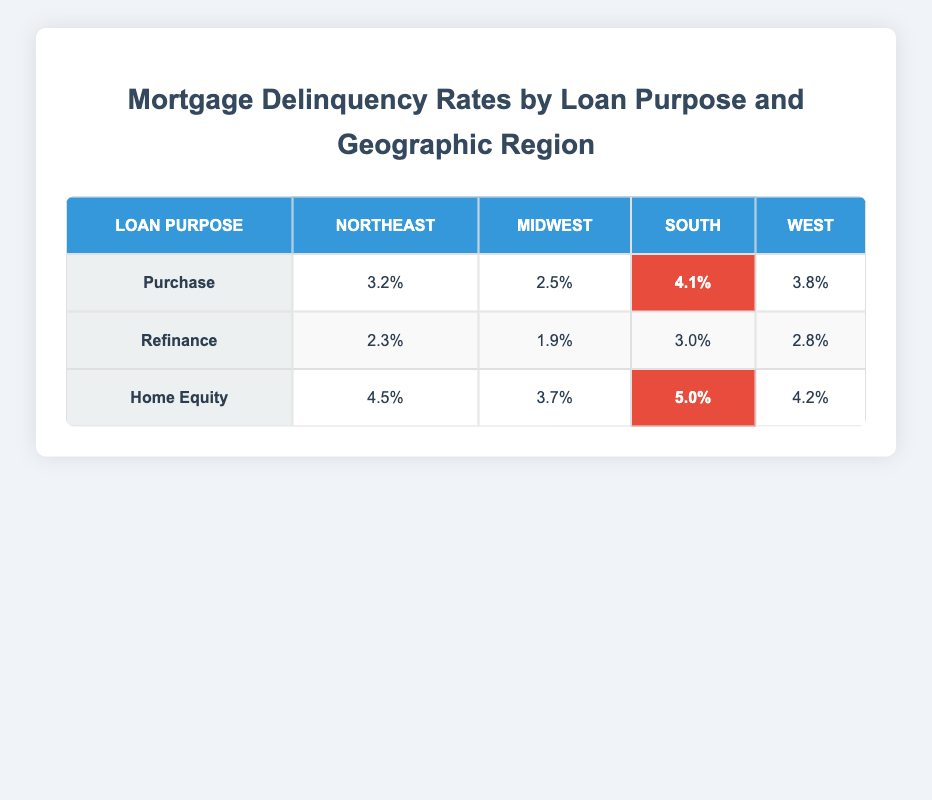What is the highest delinquency rate for Purchase loans? The table shows the delinquency rate for Purchase loans across different regions. The highest value in the South region is 4.1%.
Answer: 4.1% Which region has the lowest delinquency rate for Refinance loans? Looking at the Refinance row, the lowest delinquency rate is in the Midwest at 1.9%.
Answer: 1.9% Is the delinquency rate for Home Equity loans in the Northeast higher than in the South? The delinquency rate for Home Equity loans in the Northeast is 4.5%, while in the South it is 5.0%. Since 4.5% is less than 5.0%, the statement is false.
Answer: No What is the average delinquency rate for Purchase loans across all regions? To find the average, sum the delinquency rates for Purchase loans (3.2 + 2.5 + 4.1 + 3.8 = 13.6) and divide by the number of regions (4). So, 13.6 / 4 = 3.4%.
Answer: 3.4% Which Loan Purpose has the highest delinquency rate and what is it? By examining each Loan Purpose, Home Equity has the highest delinquency rate, specifically 5.0% in the South region.
Answer: Home Equity, 5.0% 